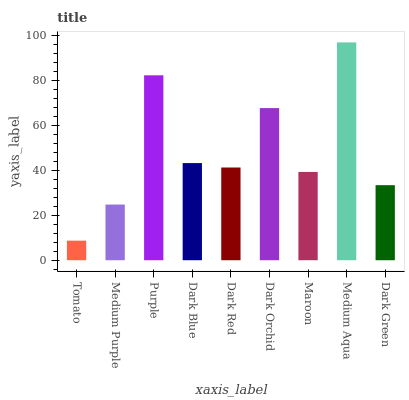Is Tomato the minimum?
Answer yes or no. Yes. Is Medium Aqua the maximum?
Answer yes or no. Yes. Is Medium Purple the minimum?
Answer yes or no. No. Is Medium Purple the maximum?
Answer yes or no. No. Is Medium Purple greater than Tomato?
Answer yes or no. Yes. Is Tomato less than Medium Purple?
Answer yes or no. Yes. Is Tomato greater than Medium Purple?
Answer yes or no. No. Is Medium Purple less than Tomato?
Answer yes or no. No. Is Dark Red the high median?
Answer yes or no. Yes. Is Dark Red the low median?
Answer yes or no. Yes. Is Dark Blue the high median?
Answer yes or no. No. Is Tomato the low median?
Answer yes or no. No. 